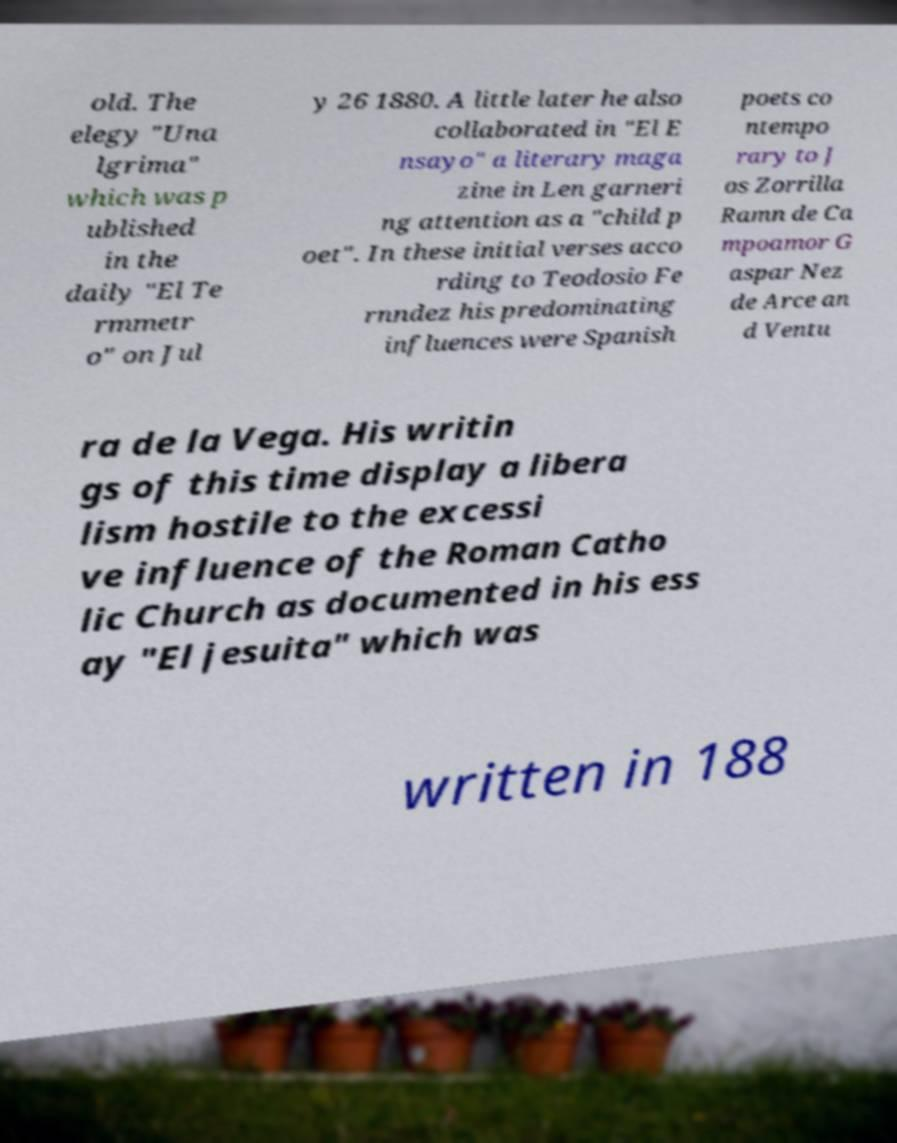What messages or text are displayed in this image? I need them in a readable, typed format. old. The elegy "Una lgrima" which was p ublished in the daily "El Te rmmetr o" on Jul y 26 1880. A little later he also collaborated in "El E nsayo" a literary maga zine in Len garneri ng attention as a "child p oet". In these initial verses acco rding to Teodosio Fe rnndez his predominating influences were Spanish poets co ntempo rary to J os Zorrilla Ramn de Ca mpoamor G aspar Nez de Arce an d Ventu ra de la Vega. His writin gs of this time display a libera lism hostile to the excessi ve influence of the Roman Catho lic Church as documented in his ess ay "El jesuita" which was written in 188 